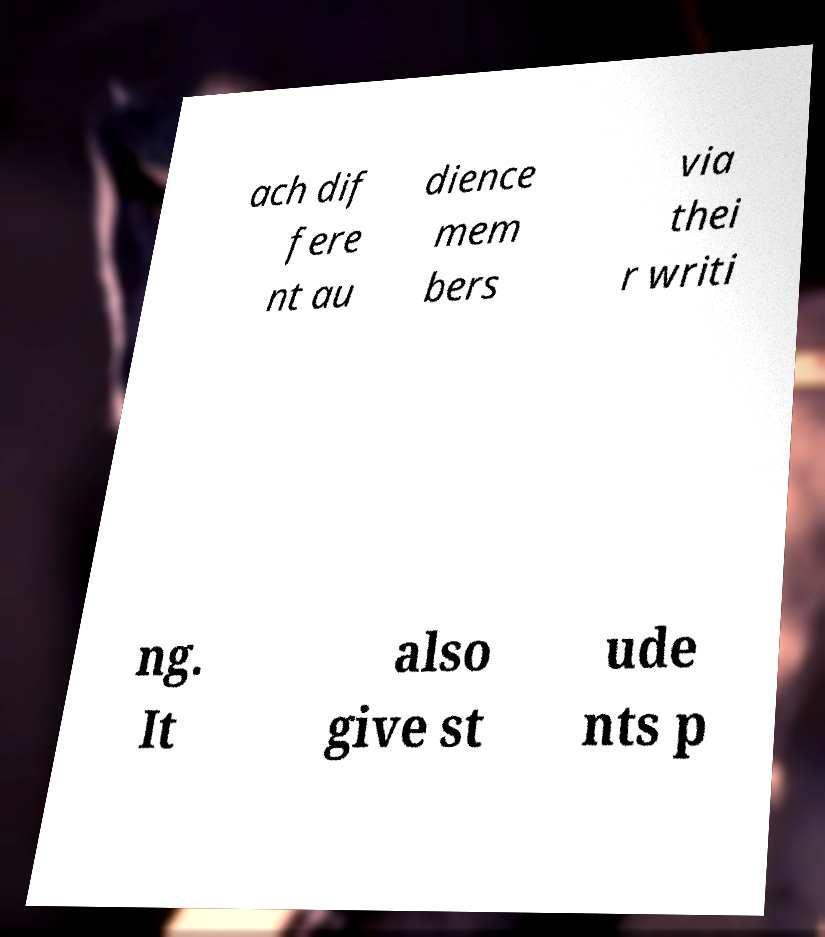Please identify and transcribe the text found in this image. ach dif fere nt au dience mem bers via thei r writi ng. It also give st ude nts p 